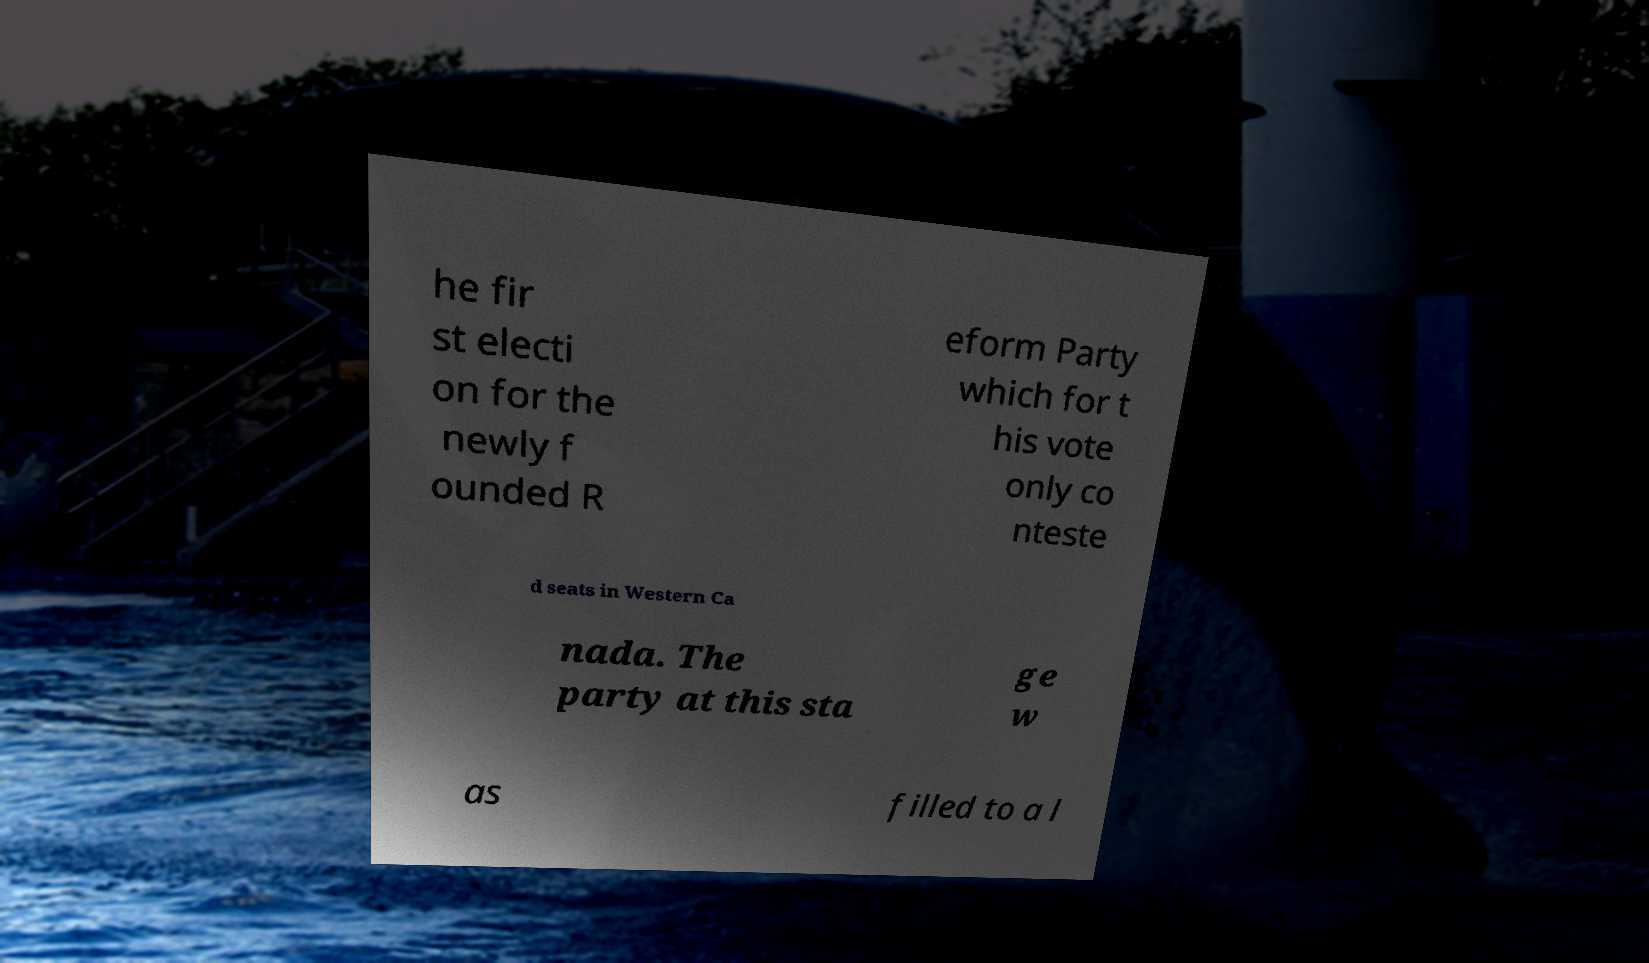There's text embedded in this image that I need extracted. Can you transcribe it verbatim? he fir st electi on for the newly f ounded R eform Party which for t his vote only co nteste d seats in Western Ca nada. The party at this sta ge w as filled to a l 